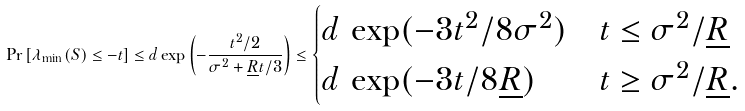Convert formula to latex. <formula><loc_0><loc_0><loc_500><loc_500>\Pr \left [ \lambda _ { \min } ( S ) \leq - t \right ] \leq d \exp \left ( - \frac { t ^ { 2 } / 2 } { \sigma ^ { 2 } + \underline { R } t / 3 } \right ) \leq \begin{cases} d \, \exp ( - 3 t ^ { 2 } / 8 \sigma ^ { 2 } ) & t \leq \sigma ^ { 2 } / \underline { R } \\ d \, \exp ( - 3 t / 8 \underline { R } ) & t \geq \sigma ^ { 2 } / \underline { R } . \end{cases}</formula> 